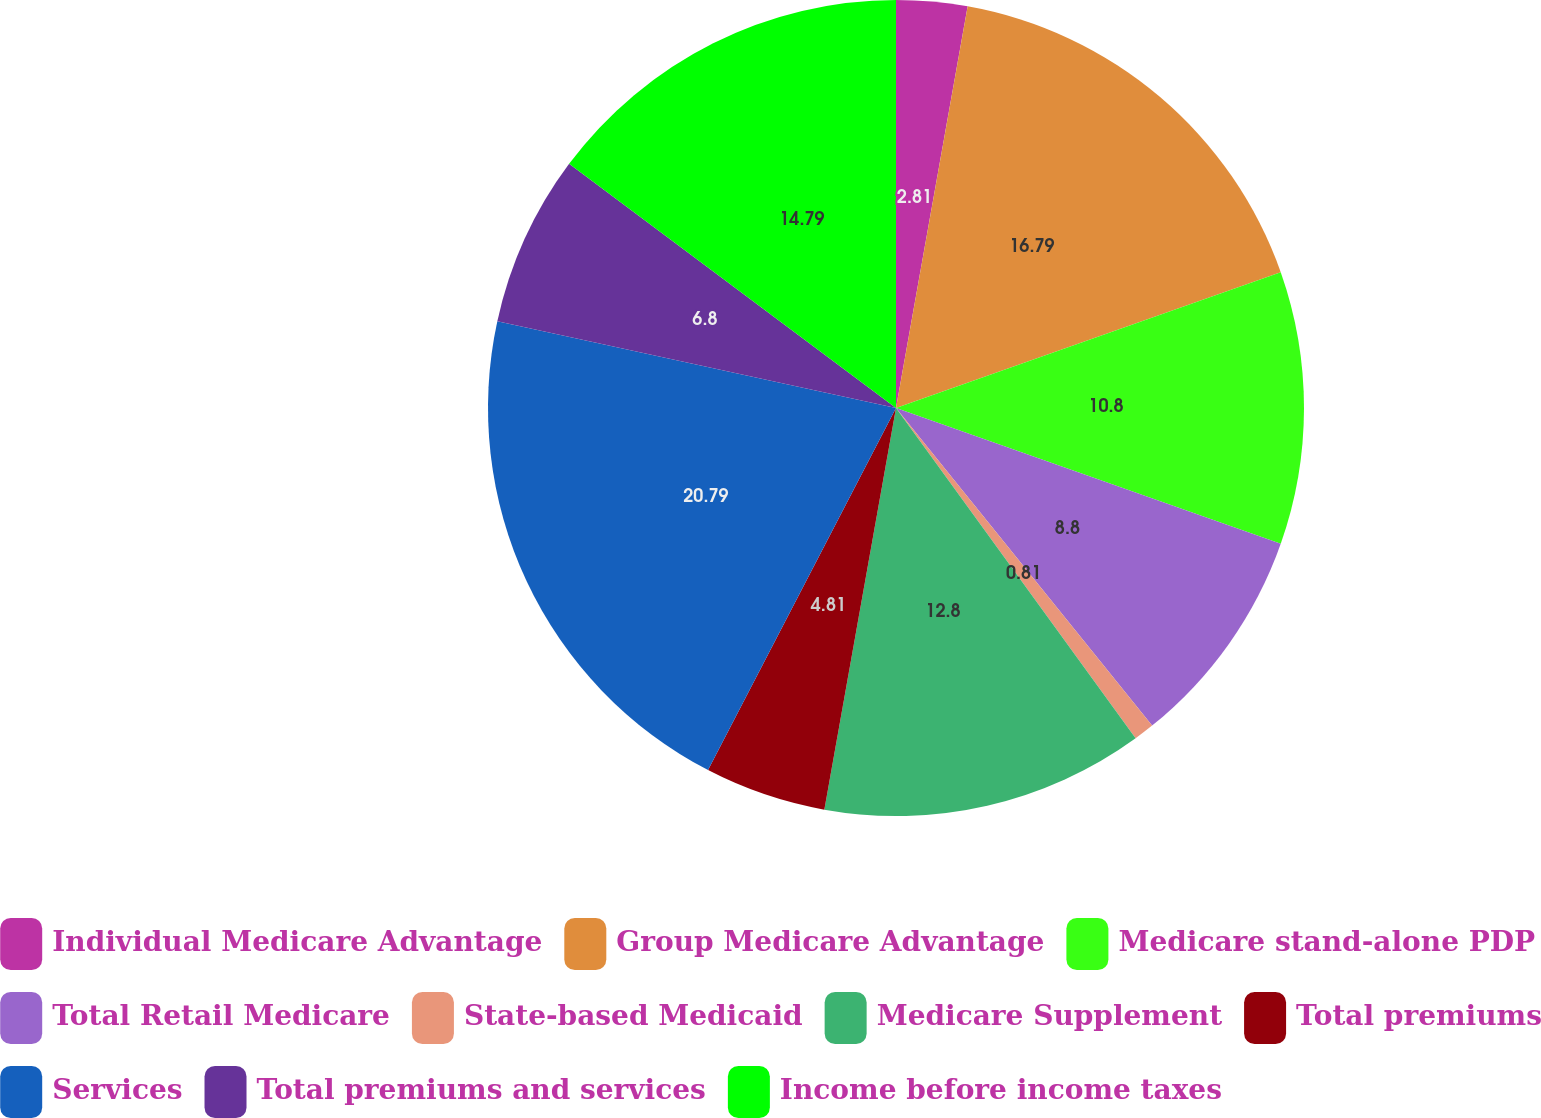Convert chart. <chart><loc_0><loc_0><loc_500><loc_500><pie_chart><fcel>Individual Medicare Advantage<fcel>Group Medicare Advantage<fcel>Medicare stand-alone PDP<fcel>Total Retail Medicare<fcel>State-based Medicaid<fcel>Medicare Supplement<fcel>Total premiums<fcel>Services<fcel>Total premiums and services<fcel>Income before income taxes<nl><fcel>2.81%<fcel>16.79%<fcel>10.8%<fcel>8.8%<fcel>0.81%<fcel>12.8%<fcel>4.81%<fcel>20.79%<fcel>6.8%<fcel>14.79%<nl></chart> 